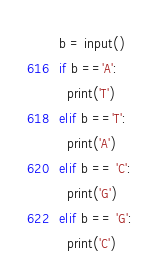Convert code to text. <code><loc_0><loc_0><loc_500><loc_500><_Python_>b = input()
if b =='A':
  print('T')
elif b =='T':
  print('A')
elif b == 'C':
  print('G')
elif b == 'G':
  print('C')</code> 